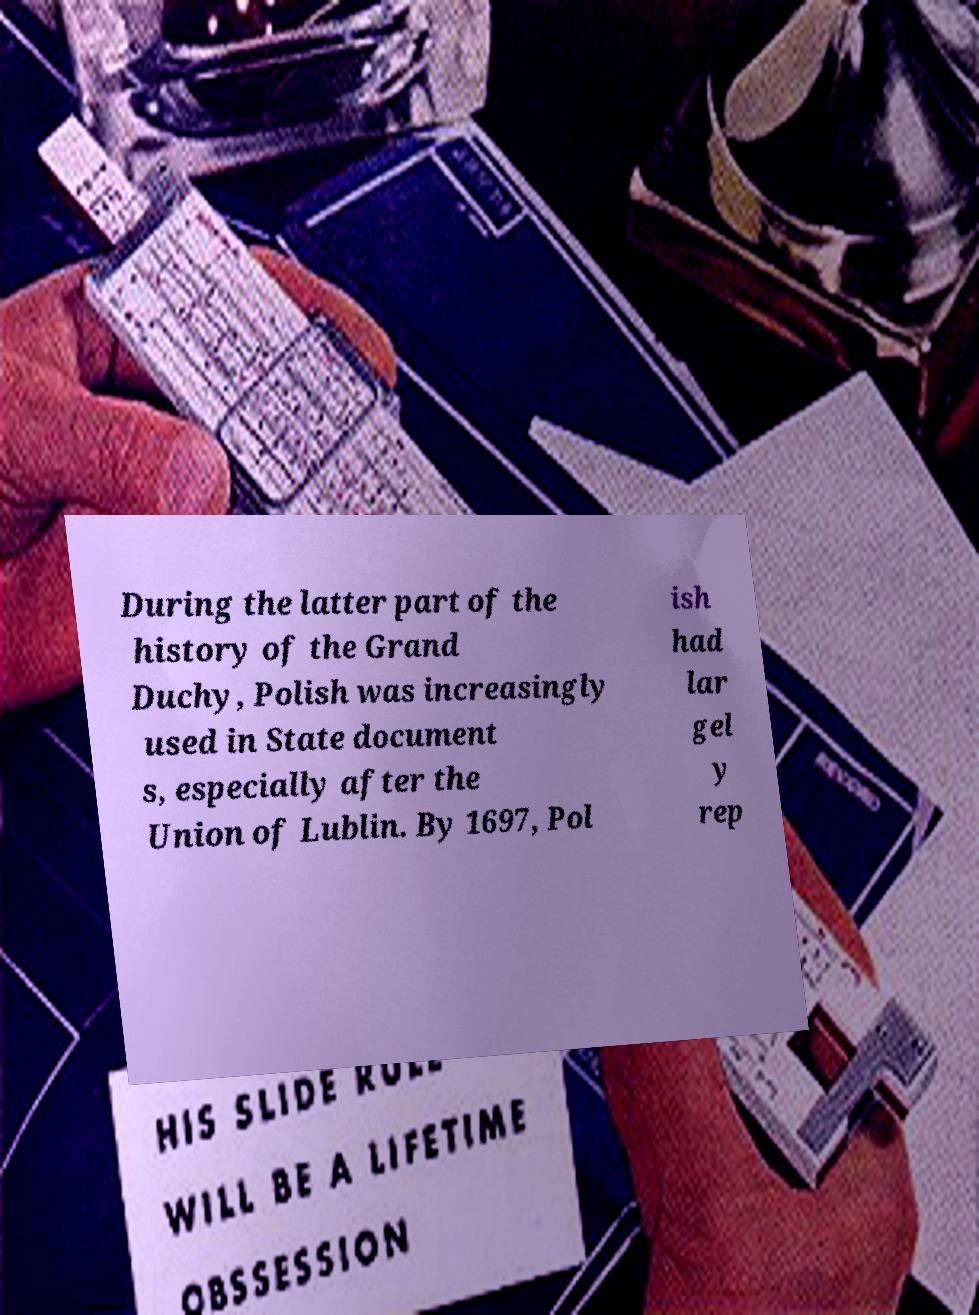Could you extract and type out the text from this image? During the latter part of the history of the Grand Duchy, Polish was increasingly used in State document s, especially after the Union of Lublin. By 1697, Pol ish had lar gel y rep 